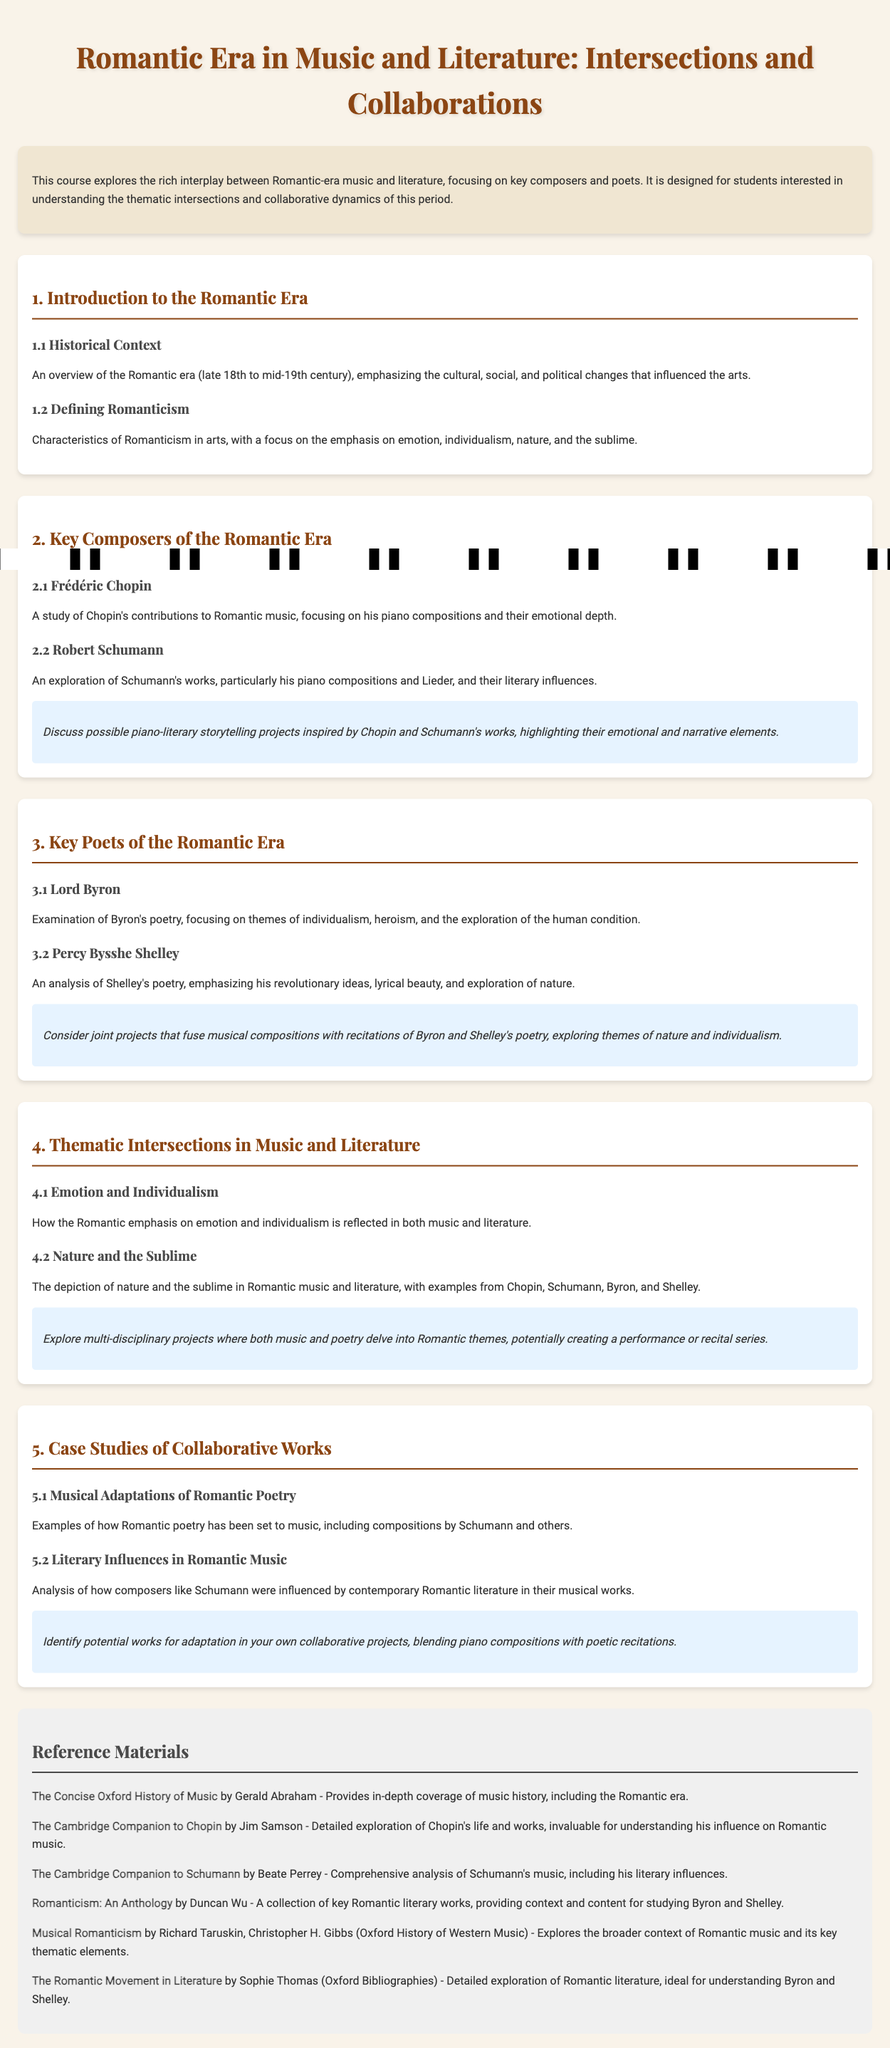What is the title of the syllabus? The title is prominently displayed at the top of the document, stating the focus of the content.
Answer: Romantic Era in Music and Literature: Intersections and Collaborations What are the two key composers analyzed in this syllabus? The syllabus specifies key composers that are central to the course content.
Answer: Chopin and Schumann Which literary figures are featured in the syllabus? The syllabus mentions poets that are significant to the Romantic era and the thematic exploration of the course.
Answer: Byron and Shelley What is one characteristic of Romanticism highlighted in the syllabus? The syllabus discusses specific features that define the Romantic movement in arts.
Answer: Emotion In what year range does the Romantic era primarily fall? The syllabus provides a timeframe for the Romantic period, essential for historical context.
Answer: Late 18th to mid-19th century What type of literary influence is discussed in connection with Robert Schumann? The syllabus indicates the relationship between Schumann's compositions and certain literary aspects.
Answer: Literary influences What thematic elements are explored in the intersection of music and literature? The syllabus outlines specific themes that are cross-referenced between music and poetry.
Answer: Emotion and Individualism In what unit are case studies of collaborative works discussed? The syllabus organizes content into units that specify different areas of focus, of which this is one.
Answer: Unit 5 What type of projects are suggested for collaboration themes? The syllabus proposes the nature of interdisciplinary work that students might engage with.
Answer: Multi-disciplinary projects 